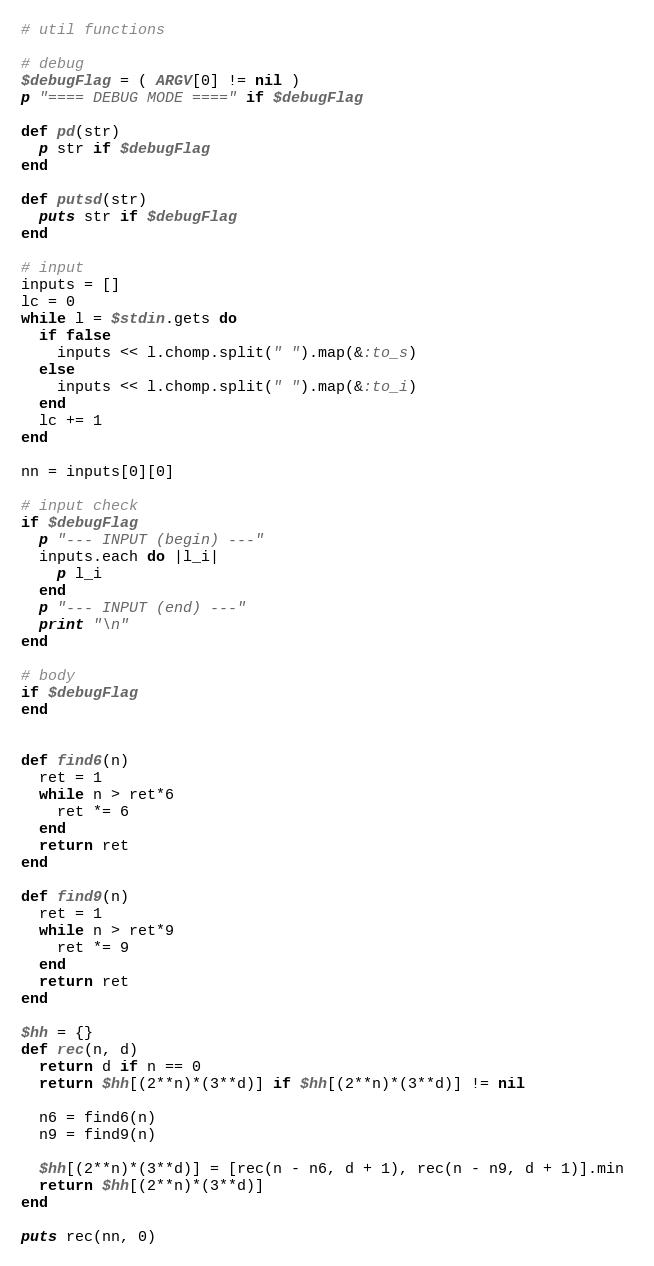Convert code to text. <code><loc_0><loc_0><loc_500><loc_500><_Ruby_># util functions

# debug
$debugFlag = ( ARGV[0] != nil )
p "==== DEBUG MODE ====" if $debugFlag

def pd(str)
  p str if $debugFlag
end

def putsd(str)
  puts str if $debugFlag
end

# input
inputs = []
lc = 0
while l = $stdin.gets do
  if false
    inputs << l.chomp.split(" ").map(&:to_s)
  else
    inputs << l.chomp.split(" ").map(&:to_i)
  end
  lc += 1
end

nn = inputs[0][0]

# input check
if $debugFlag
  p "--- INPUT (begin) ---"
  inputs.each do |l_i|
    p l_i
  end
  p "--- INPUT (end) ---"
  print "\n"
end

# body
if $debugFlag
end


def find6(n)
  ret = 1
  while n > ret*6
    ret *= 6
  end
  return ret
end

def find9(n)
  ret = 1
  while n > ret*9
    ret *= 9
  end
  return ret
end

$hh = {}
def rec(n, d)
  return d if n == 0
  return $hh[(2**n)*(3**d)] if $hh[(2**n)*(3**d)] != nil
  
  n6 = find6(n)
  n9 = find9(n)

  $hh[(2**n)*(3**d)] = [rec(n - n6, d + 1), rec(n - n9, d + 1)].min 
  return $hh[(2**n)*(3**d)]
end

puts rec(nn, 0)
</code> 